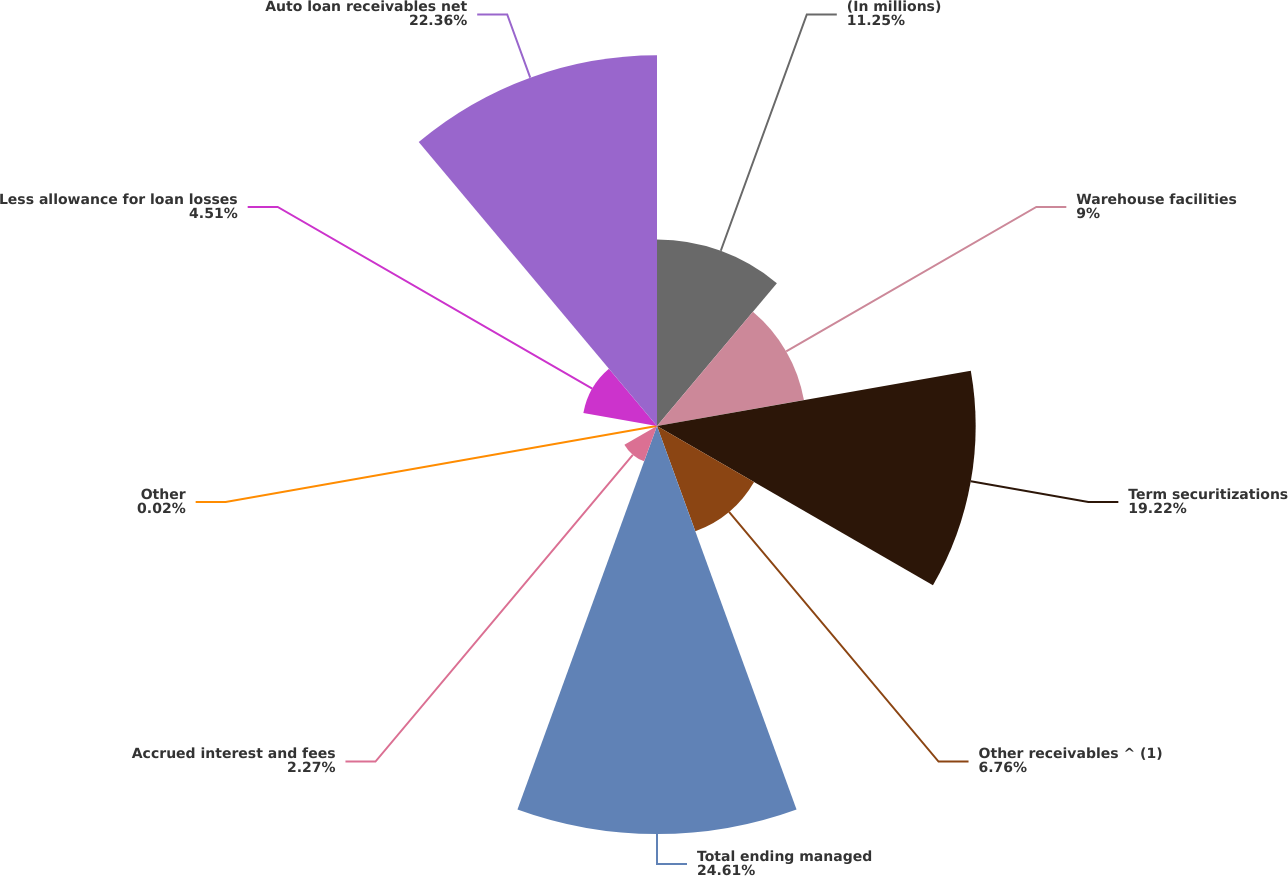Convert chart to OTSL. <chart><loc_0><loc_0><loc_500><loc_500><pie_chart><fcel>(In millions)<fcel>Warehouse facilities<fcel>Term securitizations<fcel>Other receivables ^ (1)<fcel>Total ending managed<fcel>Accrued interest and fees<fcel>Other<fcel>Less allowance for loan losses<fcel>Auto loan receivables net<nl><fcel>11.25%<fcel>9.0%<fcel>19.22%<fcel>6.76%<fcel>24.61%<fcel>2.27%<fcel>0.02%<fcel>4.51%<fcel>22.36%<nl></chart> 